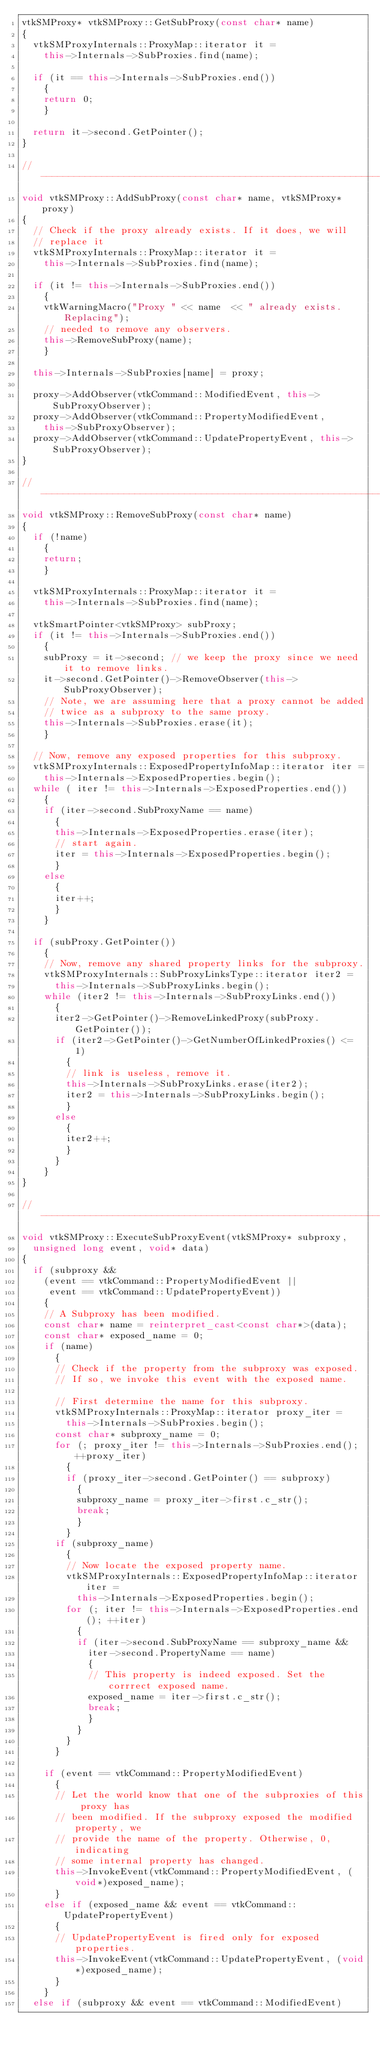Convert code to text. <code><loc_0><loc_0><loc_500><loc_500><_C++_>vtkSMProxy* vtkSMProxy::GetSubProxy(const char* name)
{
  vtkSMProxyInternals::ProxyMap::iterator it =
    this->Internals->SubProxies.find(name);

  if (it == this->Internals->SubProxies.end())
    {
    return 0;
    }

  return it->second.GetPointer();
}

//---------------------------------------------------------------------------
void vtkSMProxy::AddSubProxy(const char* name, vtkSMProxy* proxy)
{
  // Check if the proxy already exists. If it does, we will
  // replace it
  vtkSMProxyInternals::ProxyMap::iterator it =
    this->Internals->SubProxies.find(name);

  if (it != this->Internals->SubProxies.end())
    {
    vtkWarningMacro("Proxy " << name  << " already exists. Replacing");
    // needed to remove any observers.
    this->RemoveSubProxy(name);
    }

  this->Internals->SubProxies[name] = proxy;
  
  proxy->AddObserver(vtkCommand::ModifiedEvent, this->SubProxyObserver);
  proxy->AddObserver(vtkCommand::PropertyModifiedEvent, 
    this->SubProxyObserver);
  proxy->AddObserver(vtkCommand::UpdatePropertyEvent, this->SubProxyObserver);
}

//---------------------------------------------------------------------------
void vtkSMProxy::RemoveSubProxy(const char* name)
{
  if (!name)
    {
    return;
    }

  vtkSMProxyInternals::ProxyMap::iterator it =
    this->Internals->SubProxies.find(name);

  vtkSmartPointer<vtkSMProxy> subProxy;
  if (it != this->Internals->SubProxies.end())
    {
    subProxy = it->second; // we keep the proxy since we need it to remove links.
    it->second.GetPointer()->RemoveObserver(this->SubProxyObserver);
    // Note, we are assuming here that a proxy cannot be added
    // twice as a subproxy to the same proxy.
    this->Internals->SubProxies.erase(it);
    }
  
  // Now, remove any exposed properties for this subproxy.
  vtkSMProxyInternals::ExposedPropertyInfoMap::iterator iter =
    this->Internals->ExposedProperties.begin();
  while ( iter != this->Internals->ExposedProperties.end())
    {
    if (iter->second.SubProxyName == name)
      {
      this->Internals->ExposedProperties.erase(iter);
      // start again.
      iter = this->Internals->ExposedProperties.begin();
      }
    else
      {
      iter++;
      }
    }

  if (subProxy.GetPointer())
    {
    // Now, remove any shared property links for the subproxy.
    vtkSMProxyInternals::SubProxyLinksType::iterator iter2 = 
      this->Internals->SubProxyLinks.begin();
    while (iter2 != this->Internals->SubProxyLinks.end())
      {
      iter2->GetPointer()->RemoveLinkedProxy(subProxy.GetPointer());
      if (iter2->GetPointer()->GetNumberOfLinkedProxies() <= 1)
        {
        // link is useless, remove it.
        this->Internals->SubProxyLinks.erase(iter2);
        iter2 = this->Internals->SubProxyLinks.begin();
        }
      else
        {
        iter2++;
        }
      }
    }
}

//---------------------------------------------------------------------------
void vtkSMProxy::ExecuteSubProxyEvent(vtkSMProxy* subproxy, 
  unsigned long event, void* data)
{
  if (subproxy && 
    (event == vtkCommand::PropertyModifiedEvent ||
     event == vtkCommand::UpdatePropertyEvent))
    {
    // A Subproxy has been modified.
    const char* name = reinterpret_cast<const char*>(data);
    const char* exposed_name = 0;
    if (name)
      {
      // Check if the property from the subproxy was exposed.
      // If so, we invoke this event with the exposed name.
      
      // First determine the name for this subproxy.
      vtkSMProxyInternals::ProxyMap::iterator proxy_iter =
        this->Internals->SubProxies.begin();
      const char* subproxy_name = 0;
      for (; proxy_iter != this->Internals->SubProxies.end(); ++proxy_iter)
        {
        if (proxy_iter->second.GetPointer() == subproxy)
          {
          subproxy_name = proxy_iter->first.c_str();
          break;
          }
        }
      if (subproxy_name)
        {
        // Now locate the exposed property name.
        vtkSMProxyInternals::ExposedPropertyInfoMap::iterator iter =
          this->Internals->ExposedProperties.begin();
        for (; iter != this->Internals->ExposedProperties.end(); ++iter)
          {
          if (iter->second.SubProxyName == subproxy_name &&
            iter->second.PropertyName == name)
            {
            // This property is indeed exposed. Set the corrrect exposed name.
            exposed_name = iter->first.c_str();
            break;
            }
          }
        }
      }

    if (event == vtkCommand::PropertyModifiedEvent)
      {
      // Let the world know that one of the subproxies of this proxy has 
      // been modified. If the subproxy exposed the modified property, we
      // provide the name of the property. Otherwise, 0, indicating
      // some internal property has changed.
      this->InvokeEvent(vtkCommand::PropertyModifiedEvent, (void*)exposed_name);
      }
    else if (exposed_name && event == vtkCommand::UpdatePropertyEvent)
      {
      // UpdatePropertyEvent is fired only for exposed properties.
      this->InvokeEvent(vtkCommand::UpdatePropertyEvent, (void*)exposed_name);
      }
    }
  else if (subproxy && event == vtkCommand::ModifiedEvent)</code> 